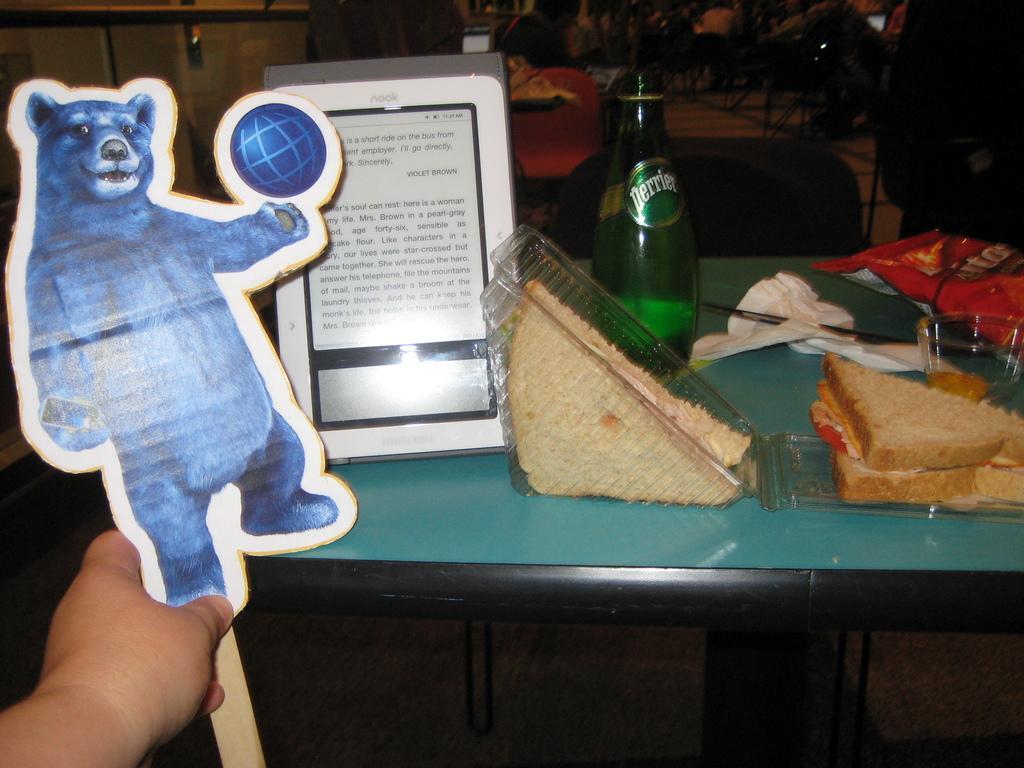Could you give a brief overview of what you see in this image? In this picture there is a table on which food items, water bottles, tissue papers and bowls were placed along with a tablet. There is a picture of a bear with a ball in front of a table. In the left side corner there is a human hand. 